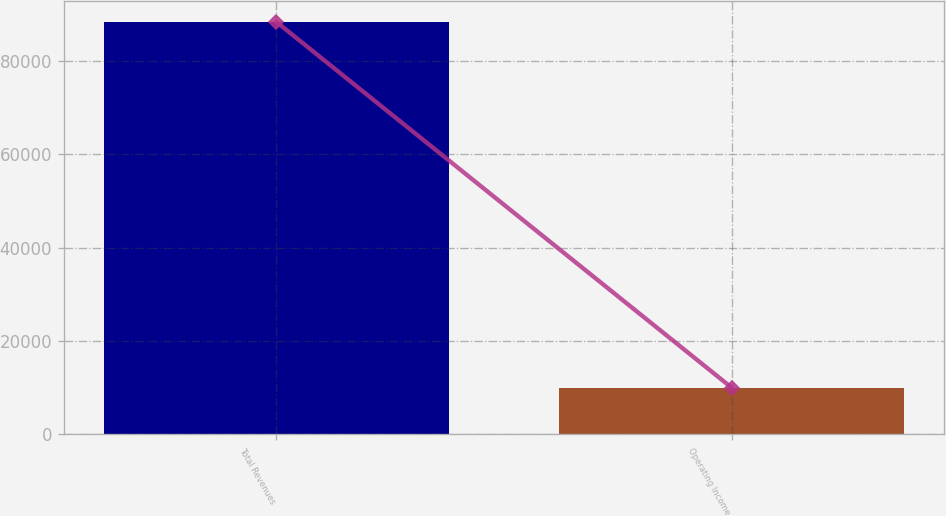Convert chart to OTSL. <chart><loc_0><loc_0><loc_500><loc_500><bar_chart><fcel>Total Revenues<fcel>Operating Income<nl><fcel>88367<fcel>10020<nl></chart> 